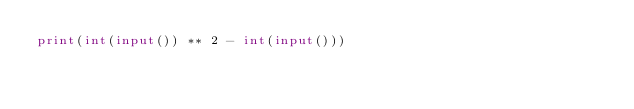Convert code to text. <code><loc_0><loc_0><loc_500><loc_500><_Python_>print(int(input()) ** 2 - int(input()))</code> 